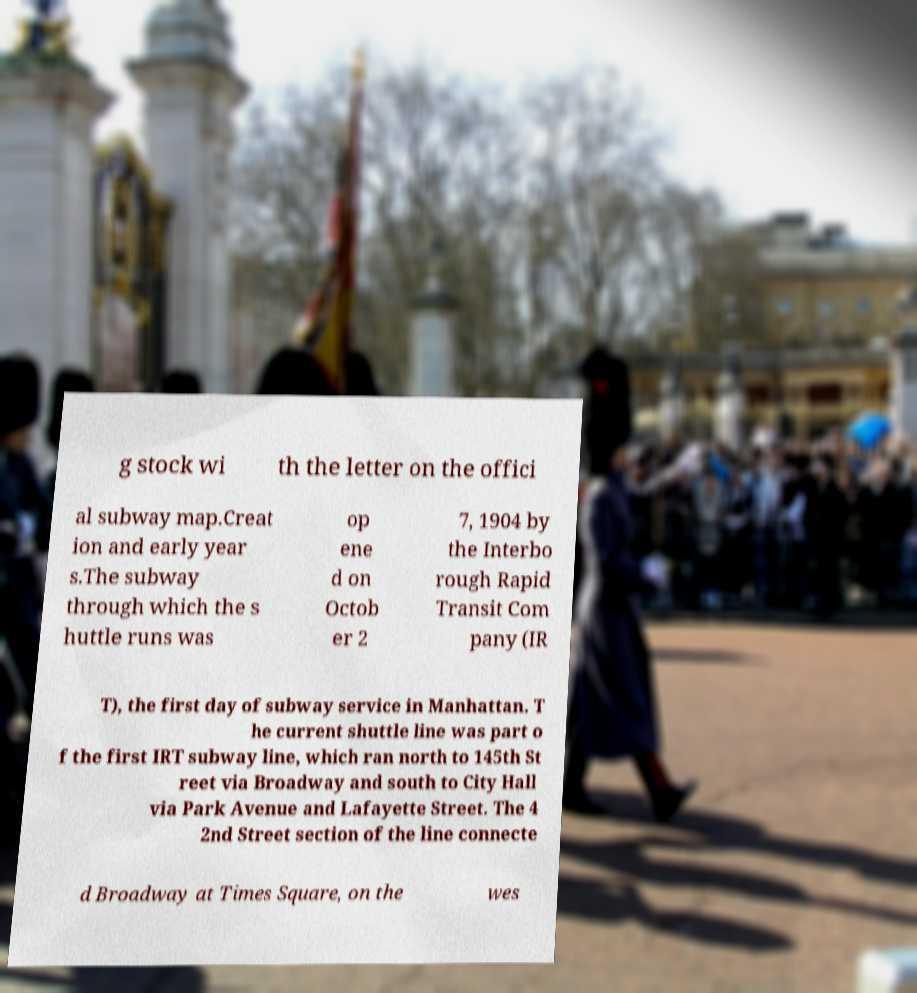Please identify and transcribe the text found in this image. g stock wi th the letter on the offici al subway map.Creat ion and early year s.The subway through which the s huttle runs was op ene d on Octob er 2 7, 1904 by the Interbo rough Rapid Transit Com pany (IR T), the first day of subway service in Manhattan. T he current shuttle line was part o f the first IRT subway line, which ran north to 145th St reet via Broadway and south to City Hall via Park Avenue and Lafayette Street. The 4 2nd Street section of the line connecte d Broadway at Times Square, on the wes 